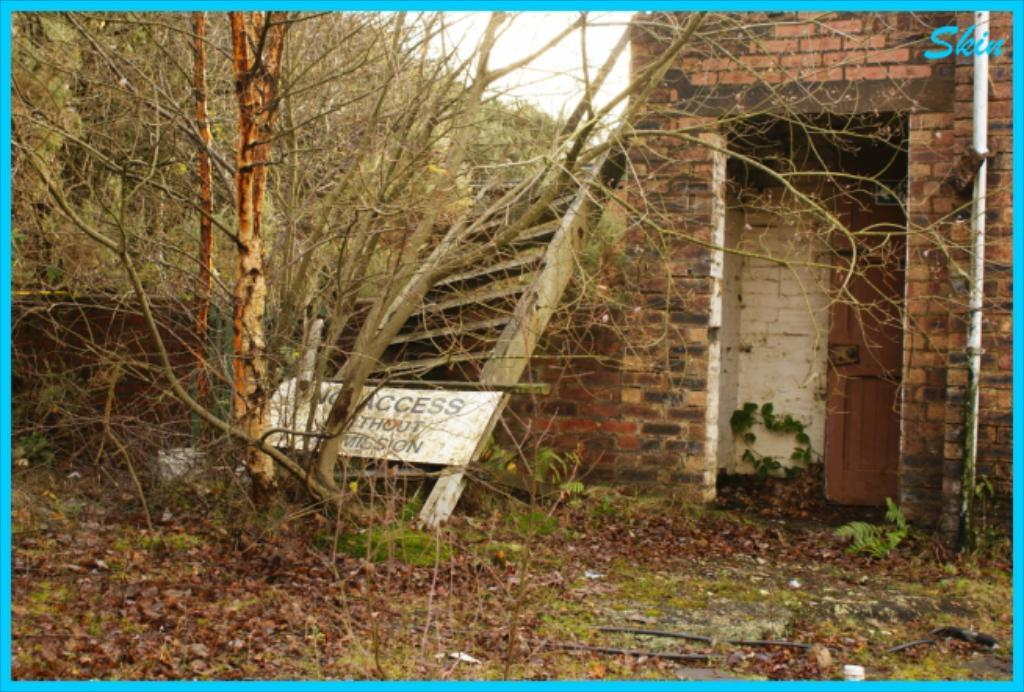<image>
Summarize the visual content of the image. A run down building with a sign that says no access without permission. 